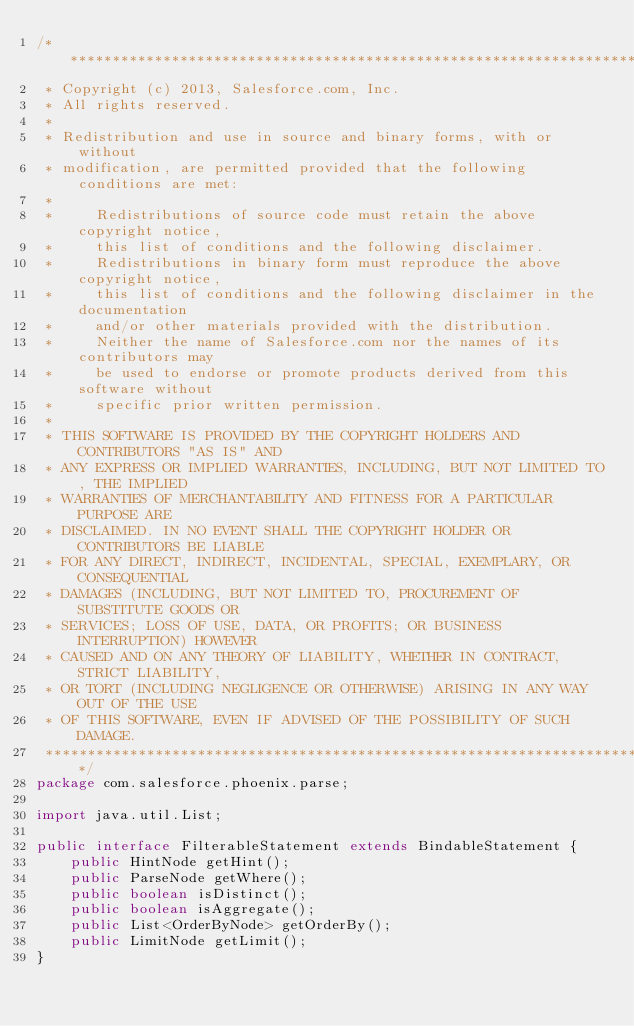<code> <loc_0><loc_0><loc_500><loc_500><_Java_>/*******************************************************************************
 * Copyright (c) 2013, Salesforce.com, Inc.
 * All rights reserved.
 * 
 * Redistribution and use in source and binary forms, with or without
 * modification, are permitted provided that the following conditions are met:
 * 
 *     Redistributions of source code must retain the above copyright notice,
 *     this list of conditions and the following disclaimer.
 *     Redistributions in binary form must reproduce the above copyright notice,
 *     this list of conditions and the following disclaimer in the documentation
 *     and/or other materials provided with the distribution.
 *     Neither the name of Salesforce.com nor the names of its contributors may 
 *     be used to endorse or promote products derived from this software without 
 *     specific prior written permission.
 * 
 * THIS SOFTWARE IS PROVIDED BY THE COPYRIGHT HOLDERS AND CONTRIBUTORS "AS IS" AND
 * ANY EXPRESS OR IMPLIED WARRANTIES, INCLUDING, BUT NOT LIMITED TO, THE IMPLIED
 * WARRANTIES OF MERCHANTABILITY AND FITNESS FOR A PARTICULAR PURPOSE ARE
 * DISCLAIMED. IN NO EVENT SHALL THE COPYRIGHT HOLDER OR CONTRIBUTORS BE LIABLE 
 * FOR ANY DIRECT, INDIRECT, INCIDENTAL, SPECIAL, EXEMPLARY, OR CONSEQUENTIAL 
 * DAMAGES (INCLUDING, BUT NOT LIMITED TO, PROCUREMENT OF SUBSTITUTE GOODS OR 
 * SERVICES; LOSS OF USE, DATA, OR PROFITS; OR BUSINESS INTERRUPTION) HOWEVER 
 * CAUSED AND ON ANY THEORY OF LIABILITY, WHETHER IN CONTRACT, STRICT LIABILITY, 
 * OR TORT (INCLUDING NEGLIGENCE OR OTHERWISE) ARISING IN ANY WAY OUT OF THE USE 
 * OF THIS SOFTWARE, EVEN IF ADVISED OF THE POSSIBILITY OF SUCH DAMAGE.
 ******************************************************************************/
package com.salesforce.phoenix.parse;

import java.util.List;

public interface FilterableStatement extends BindableStatement {
    public HintNode getHint();
    public ParseNode getWhere();
    public boolean isDistinct();
    public boolean isAggregate();
    public List<OrderByNode> getOrderBy();
    public LimitNode getLimit();
}
</code> 